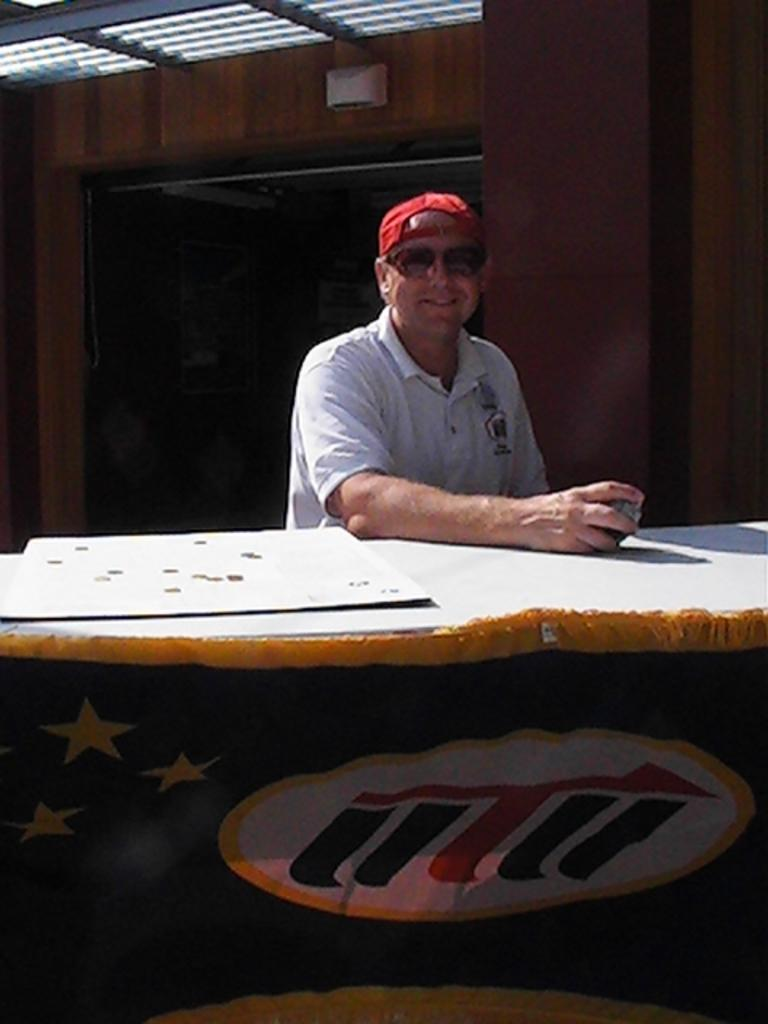Who is present in the image? A: There is a man in the image. What is the man wearing on his upper body? The man is wearing a white shirt. What type of headwear is the man wearing? The man is wearing a red hat. What is the man doing in the image? The man is sitting on a chair. What furniture is visible in the image? There is a table in the image. What is covering the table? There is a sheet on the table. What type of flowers can be seen growing near the man's feet in the image? There are no flowers present in the image; the man is sitting on a chair with a table and a sheet nearby. 